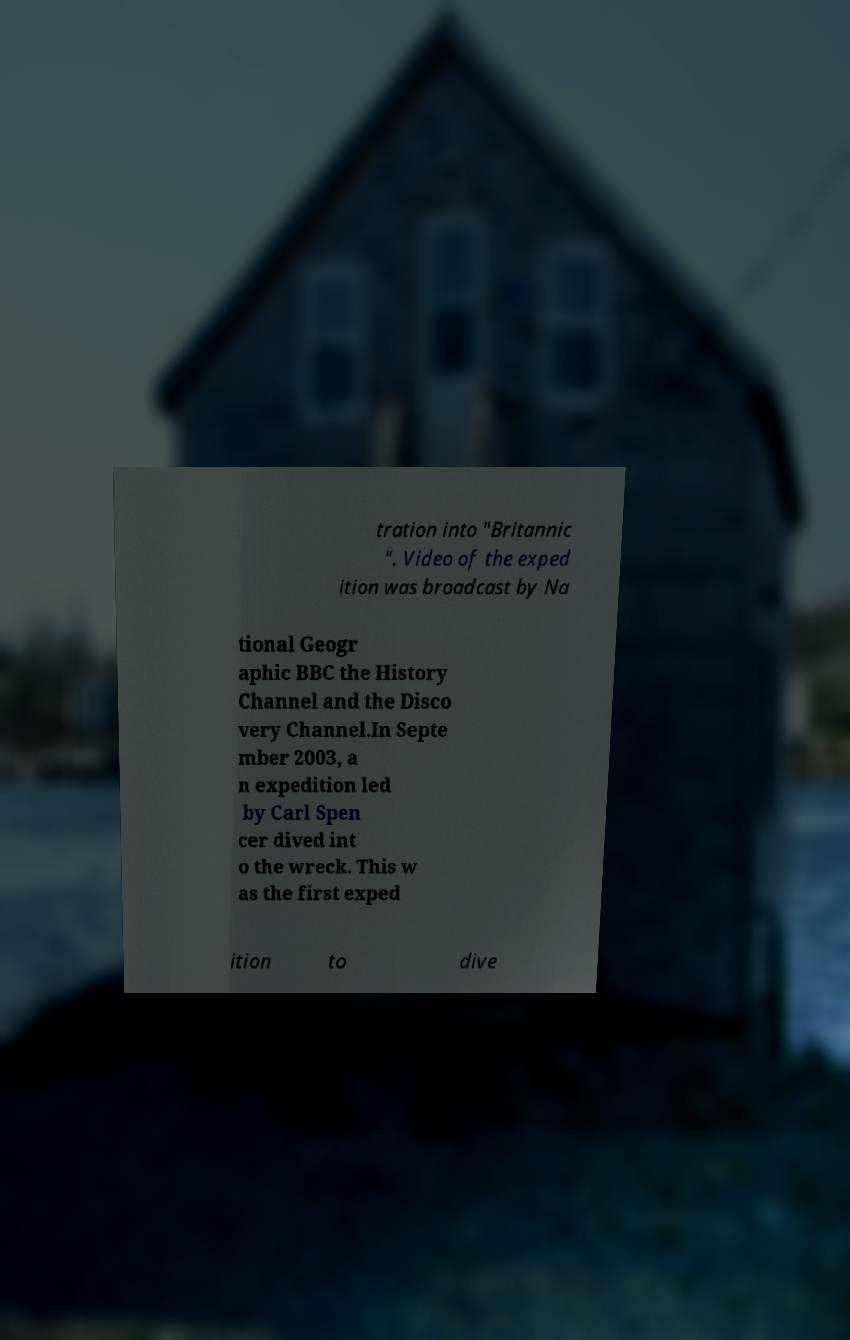Please read and relay the text visible in this image. What does it say? tration into "Britannic ". Video of the exped ition was broadcast by Na tional Geogr aphic BBC the History Channel and the Disco very Channel.In Septe mber 2003, a n expedition led by Carl Spen cer dived int o the wreck. This w as the first exped ition to dive 